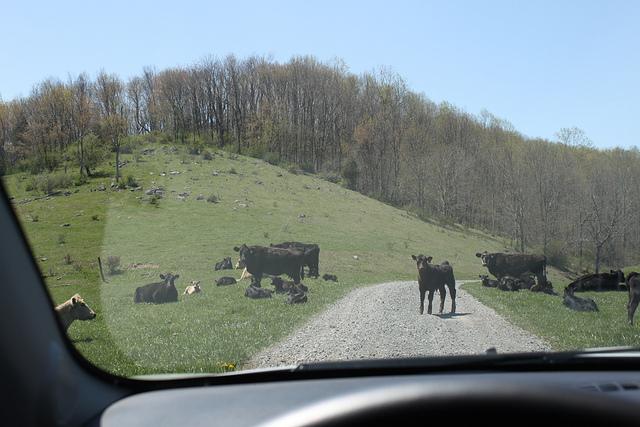What kind of animal is this?
Be succinct. Cow. Why is the nature scene partially obstructed?
Keep it brief. Yes. What is standing in the road?
Concise answer only. Cow. What number of animals are standing on the left side of the road?
Quick response, please. 2. Where would you have to be to see this sight?
Answer briefly. Farm. Where is the photo taken from?
Keep it brief. Car. What is standing on the ground?
Give a very brief answer. Cows. 